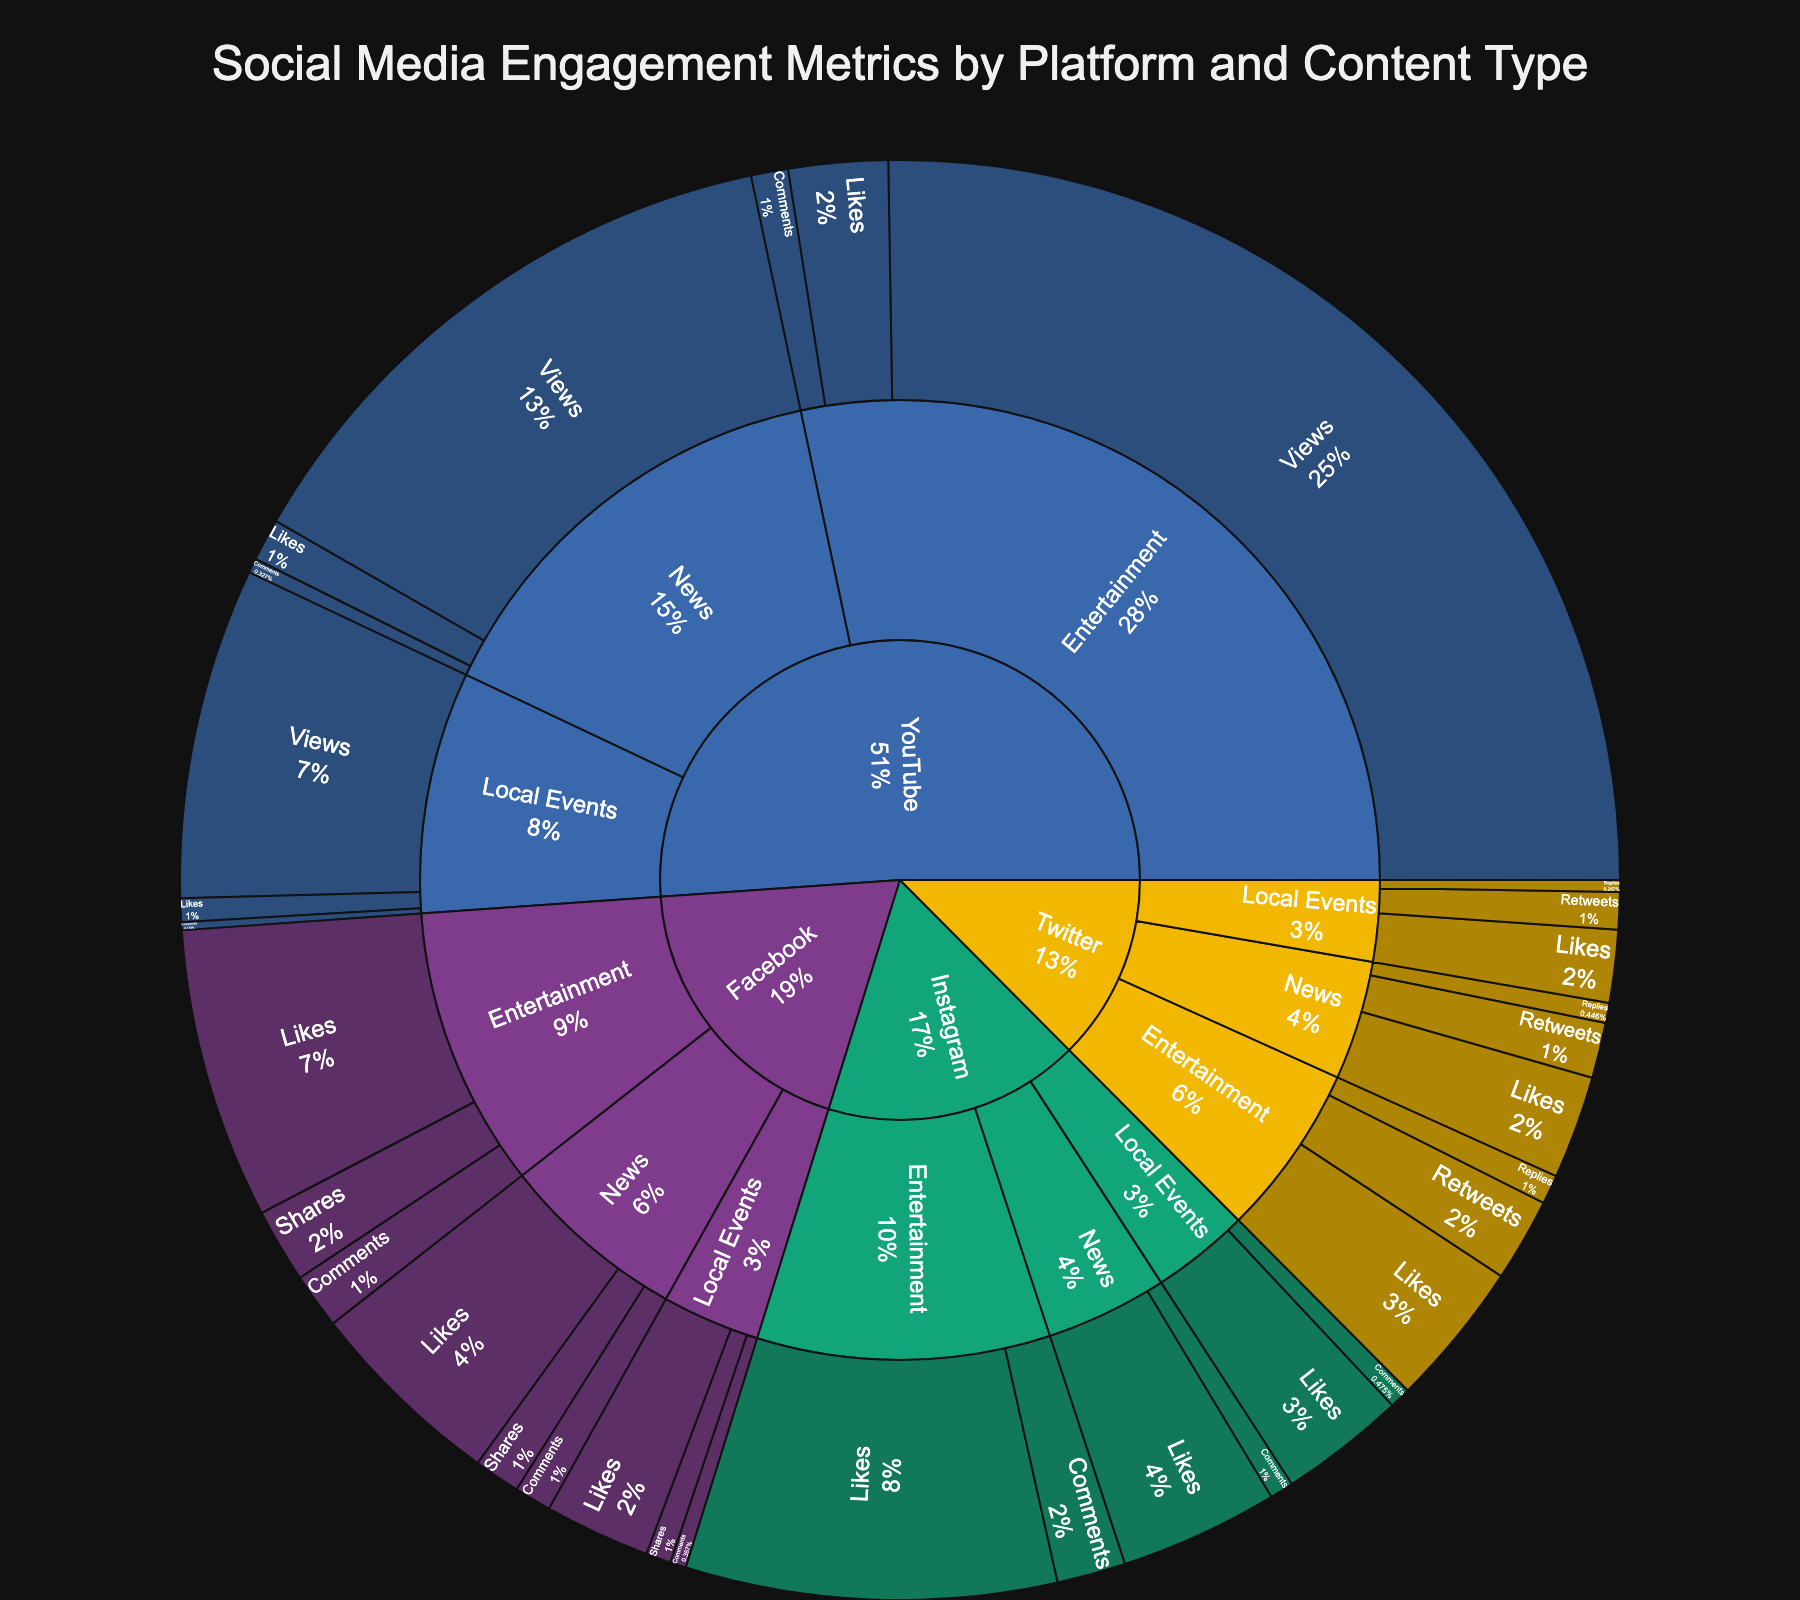What's the main title of the sunburst plot? The title of the plot is usually found at the top center and is often the most prominent text in the figure. Based on the code, the title is set to 'Social Media Engagement Metrics by Platform and Content Type.'
Answer: Social Media Engagement Metrics by Platform and Content Type Which platform has the highest total engagement for Entertainment content? To answer this, observe the segments corresponding to the 'Entertainment' category under each platform in the sunburst plot. Check the size of these segments to see which one is the largest.
Answer: YouTube How many engagement metric types are there for Twitter's Local Events content? Look at the sub-segments under Twitter -> Local Events. Each sub-segment represents a different engagement metric. Count these sub-segments.
Answer: Three Between Facebook and Instagram, which platform has more likes for News content? Compare the size of the 'Likes' segments under 'News' for both Facebook and Instagram. The larger segment indicates the platform with more likes.
Answer: Facebook What's the total number of comments received on News content across all platforms? Find the 'Comments' segment under 'News' for each platform and add their values together.
Answer: 7,900 Which content type has the least engagement on YouTube, and what is the metric? Examine the sub-segments under YouTube for each content type and determine which one has the smallest total engagement. Identify the content type and corresponding metric from this segment.
Answer: Local Events, Comments Compare the total number of shares for News content on Facebook with the number of retweets for News content on Twitter. Which is higher? Look at the 'Shares' segment under 'News' for Facebook and the 'Retweets' segment under 'News' for Twitter. By comparing their sizes, determine which one is larger.
Answer: Facebook Shares What percentage of Instagram's total engagement for 'Entertainment' content does the 'Likes' metric represent? Find the 'Likes' sub-segment under 'Entertainment' for Instagram. The percentage can be observed directly from the text on the segment or inferred based on its size relative to other segments.
Answer: Approximately 84.28% Which platform has the highest engagement for Local Events content and what is the primary metric driving this? Identify the segment for 'Local Events' under each platform and determine which one is the largest. Look at the primary metric (sub-segment) contributing most to this segment's size.
Answer: YouTube, Views 